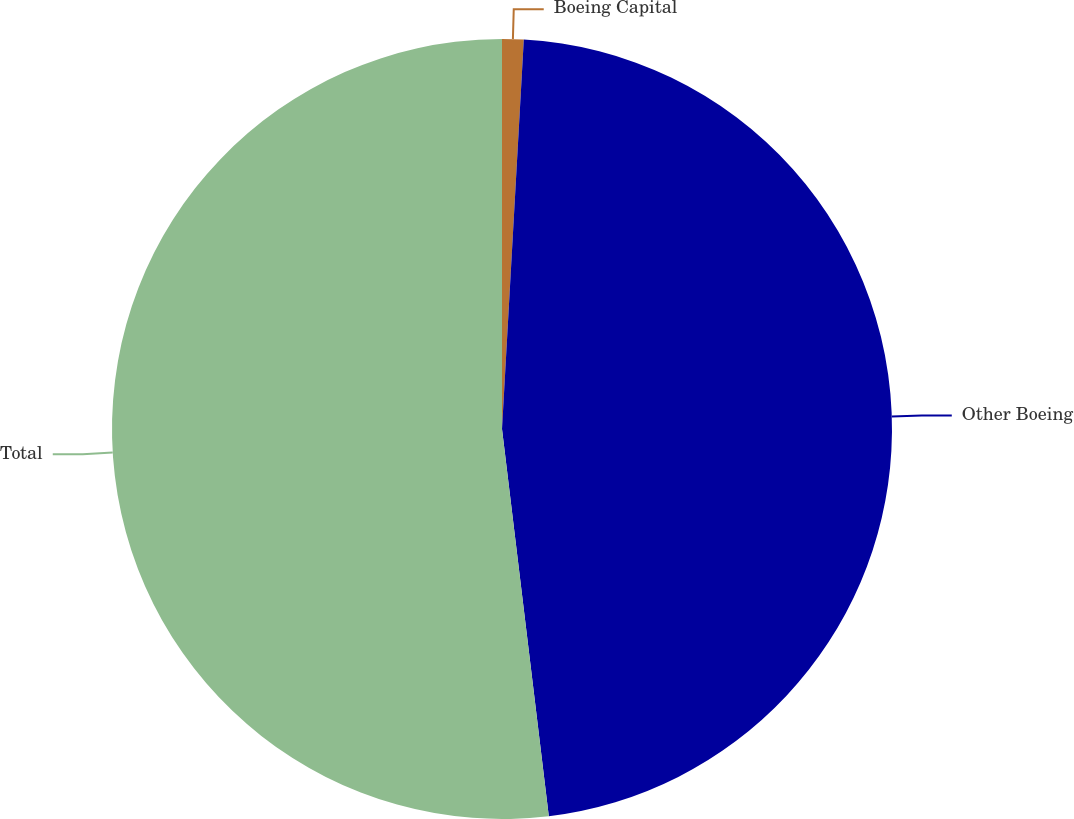Convert chart. <chart><loc_0><loc_0><loc_500><loc_500><pie_chart><fcel>Boeing Capital<fcel>Other Boeing<fcel>Total<nl><fcel>0.89%<fcel>47.19%<fcel>51.91%<nl></chart> 